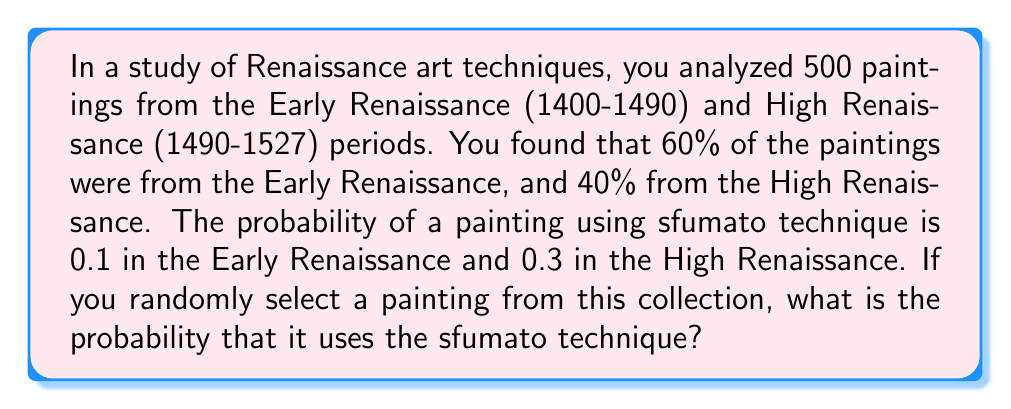Provide a solution to this math problem. Let's approach this problem using the law of total probability. We'll break it down step by step:

1) Let's define our events:
   E: The painting is from the Early Renaissance
   H: The painting is from the High Renaissance
   S: The painting uses sfumato technique

2) We're given the following probabilities:
   $P(E) = 0.6$ (60% of paintings are from Early Renaissance)
   $P(H) = 0.4$ (40% of paintings are from High Renaissance)
   $P(S|E) = 0.1$ (Probability of sfumato in Early Renaissance)
   $P(S|H) = 0.3$ (Probability of sfumato in High Renaissance)

3) The law of total probability states:
   $P(S) = P(S|E) \cdot P(E) + P(S|H) \cdot P(H)$

4) Let's substitute our values:
   $P(S) = 0.1 \cdot 0.6 + 0.3 \cdot 0.4$

5) Now we can calculate:
   $P(S) = 0.06 + 0.12 = 0.18$

Therefore, the probability that a randomly selected painting uses the sfumato technique is 0.18 or 18%.
Answer: 0.18 or 18% 